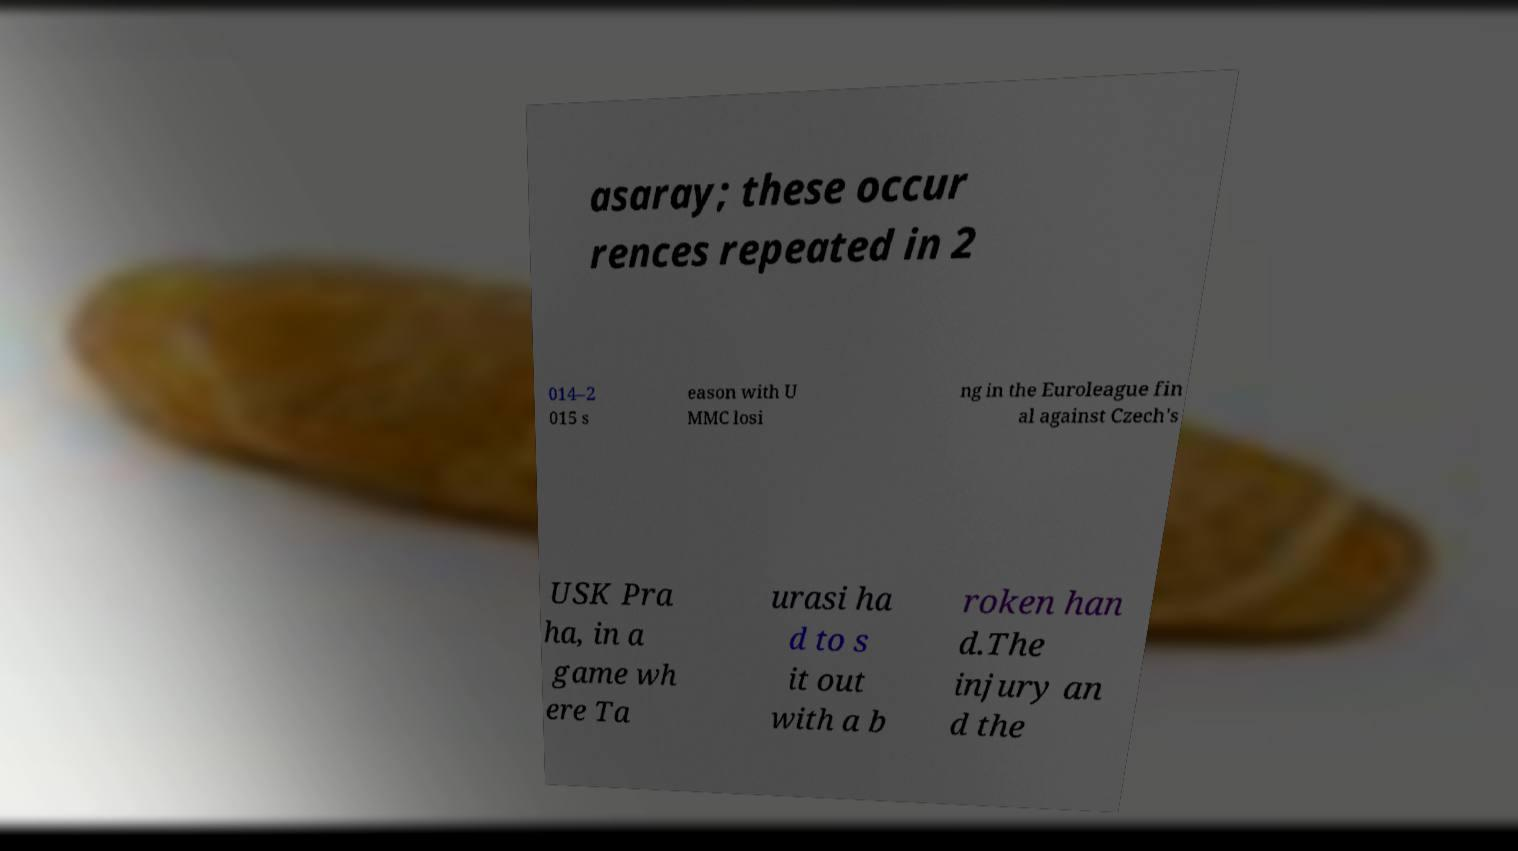What messages or text are displayed in this image? I need them in a readable, typed format. asaray; these occur rences repeated in 2 014–2 015 s eason with U MMC losi ng in the Euroleague fin al against Czech's USK Pra ha, in a game wh ere Ta urasi ha d to s it out with a b roken han d.The injury an d the 